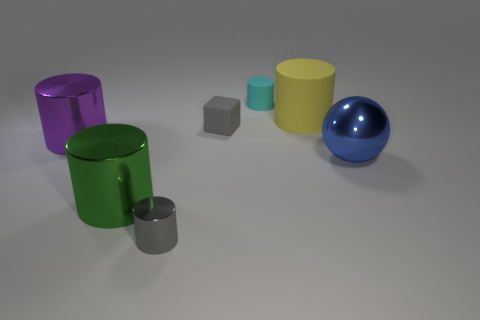Subtract all yellow cylinders. How many cylinders are left? 4 Add 3 large blue metal blocks. How many objects exist? 10 Subtract all purple cylinders. How many cylinders are left? 4 Subtract all balls. How many objects are left? 6 Subtract 3 cylinders. How many cylinders are left? 2 Subtract 1 yellow cylinders. How many objects are left? 6 Subtract all purple cylinders. Subtract all green blocks. How many cylinders are left? 4 Subtract all small gray metallic cylinders. Subtract all purple metallic cylinders. How many objects are left? 5 Add 2 small gray blocks. How many small gray blocks are left? 3 Add 4 tiny gray matte cubes. How many tiny gray matte cubes exist? 5 